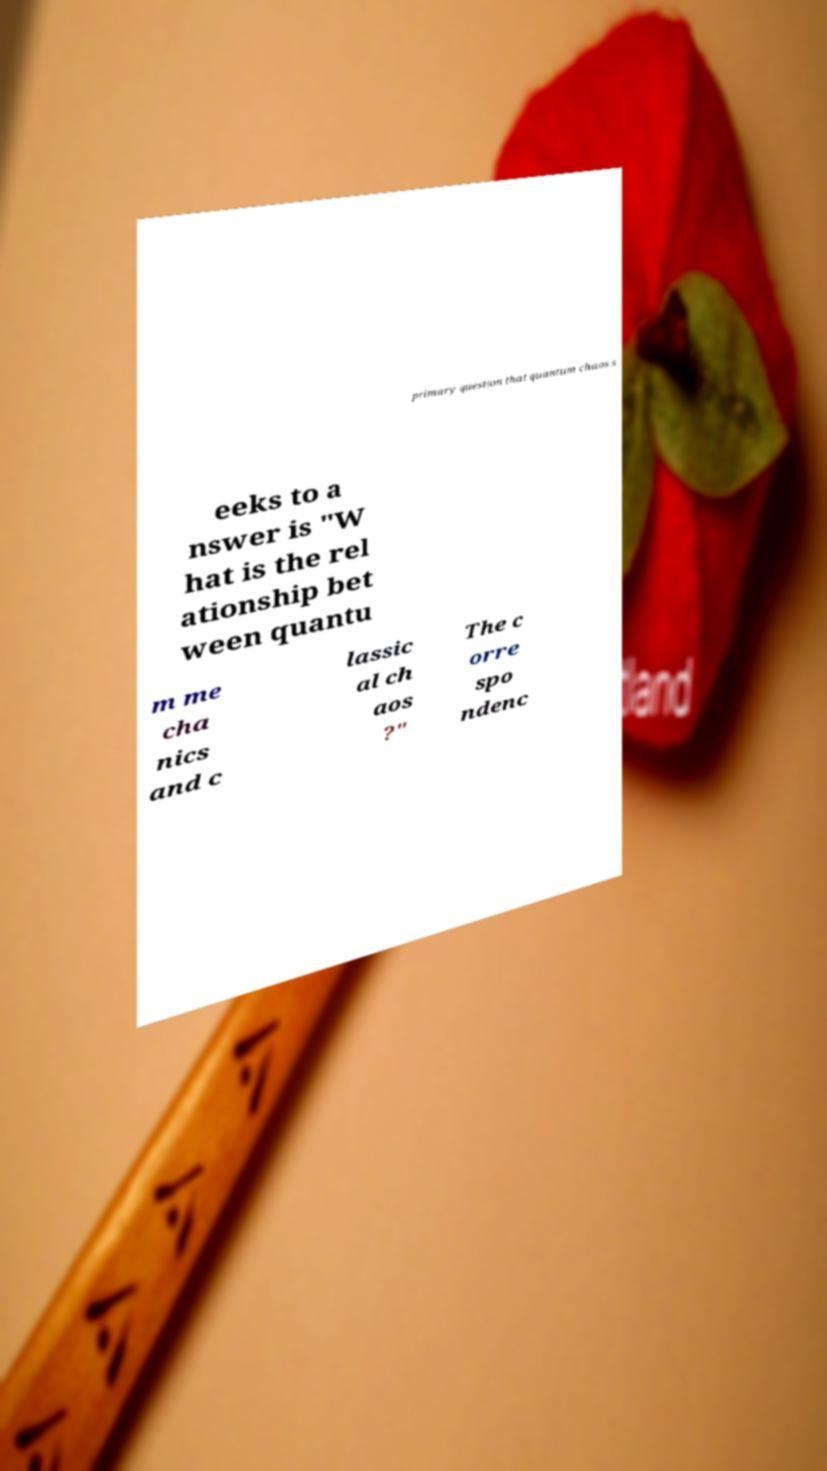Could you extract and type out the text from this image? primary question that quantum chaos s eeks to a nswer is "W hat is the rel ationship bet ween quantu m me cha nics and c lassic al ch aos ?" The c orre spo ndenc 